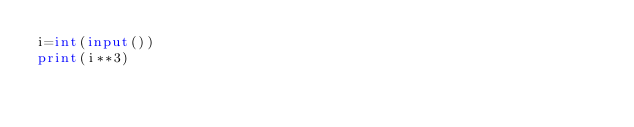<code> <loc_0><loc_0><loc_500><loc_500><_Python_>i=int(input())
print(i**3)</code> 